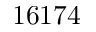<formula> <loc_0><loc_0><loc_500><loc_500>1 6 1 7 4</formula> 